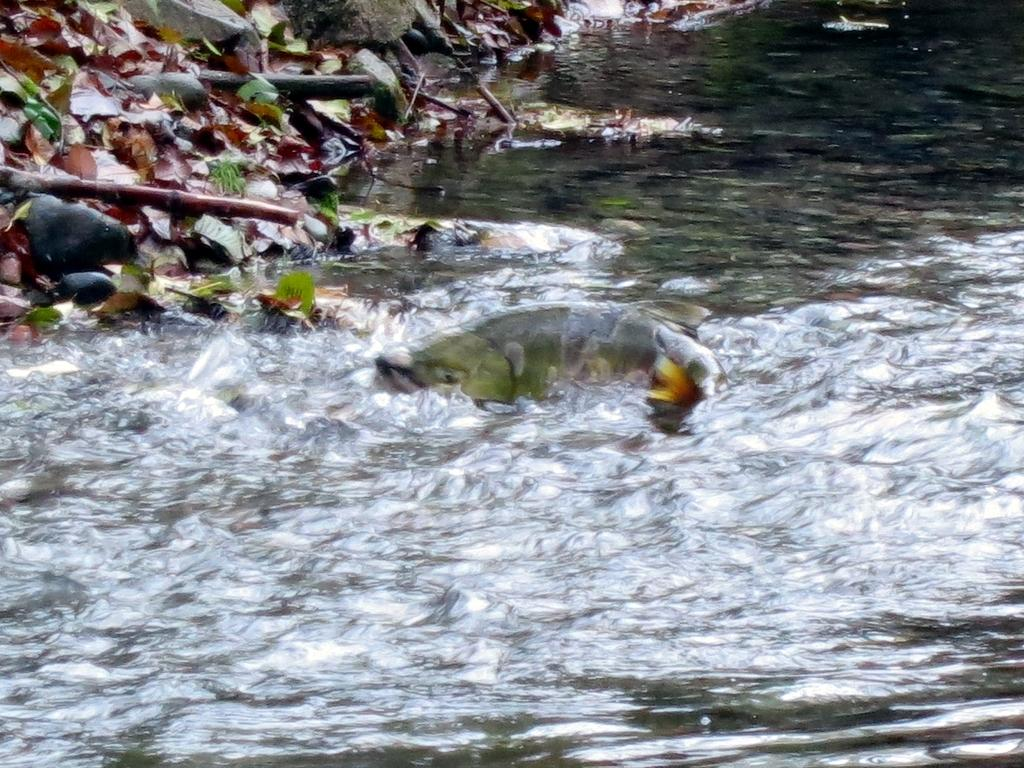What is in the water in the image? There is a fish in the water. What can be seen on the top left side of the image? There are dry leaves, wooden sticks, and rocks on the top left side of the image. Where is the porter carrying the luggage in the image? There is no porter carrying luggage in the image. 